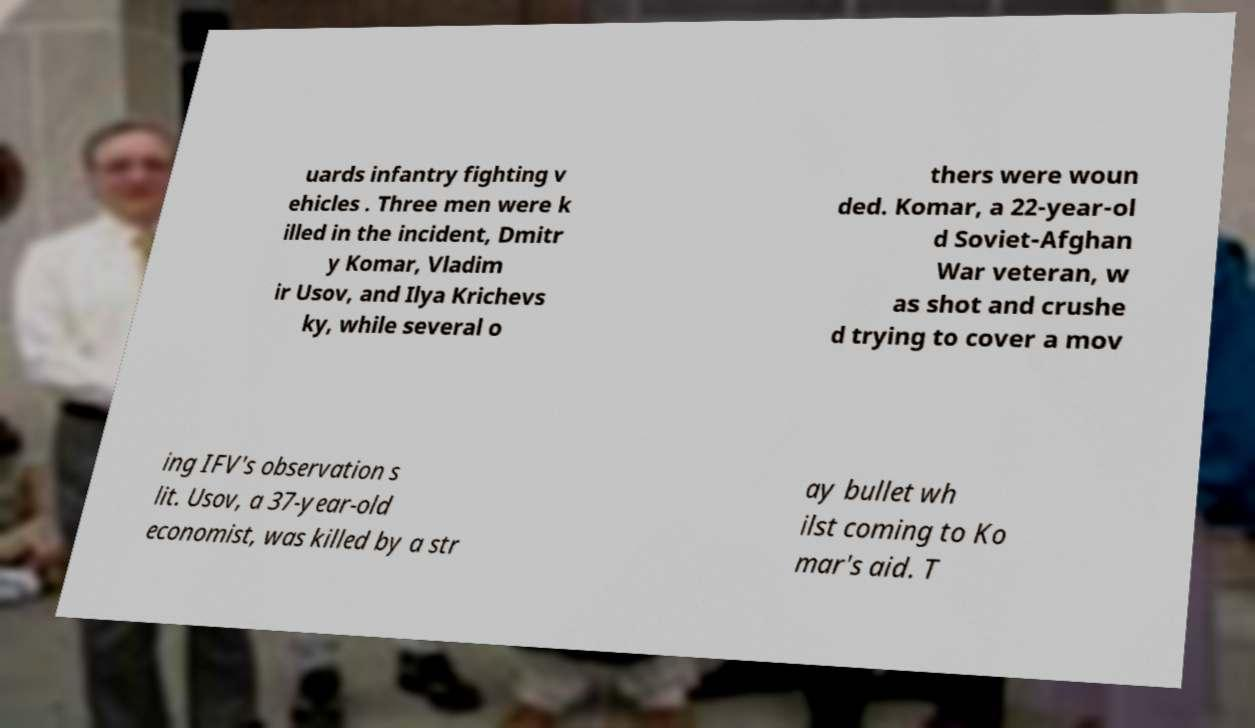What messages or text are displayed in this image? I need them in a readable, typed format. uards infantry fighting v ehicles . Three men were k illed in the incident, Dmitr y Komar, Vladim ir Usov, and Ilya Krichevs ky, while several o thers were woun ded. Komar, a 22-year-ol d Soviet-Afghan War veteran, w as shot and crushe d trying to cover a mov ing IFV's observation s lit. Usov, a 37-year-old economist, was killed by a str ay bullet wh ilst coming to Ko mar's aid. T 